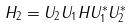Convert formula to latex. <formula><loc_0><loc_0><loc_500><loc_500>H _ { 2 } = U _ { 2 } U _ { 1 } H U _ { 1 } ^ { * } U _ { 2 } ^ { * }</formula> 